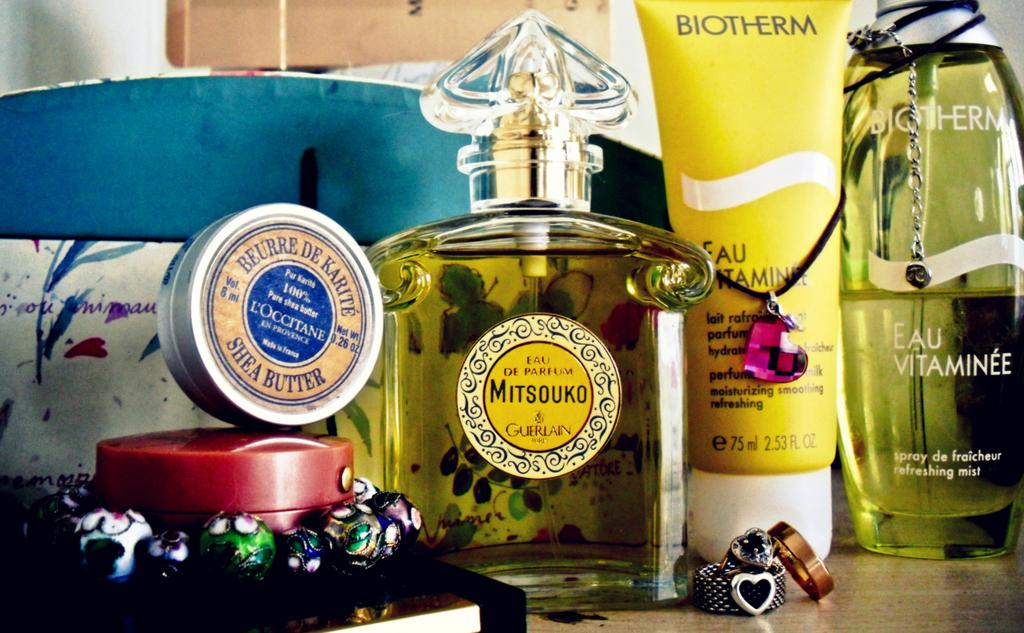<image>
Create a compact narrative representing the image presented. Beauty products laying on a shelf, one of them being shea butter in a metal tin 